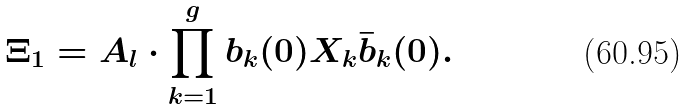Convert formula to latex. <formula><loc_0><loc_0><loc_500><loc_500>\Xi _ { 1 } = A _ { l } \cdot \prod _ { k = 1 } ^ { g } b _ { k } ( 0 ) X _ { k } { \bar { b } } _ { k } ( 0 ) .</formula> 